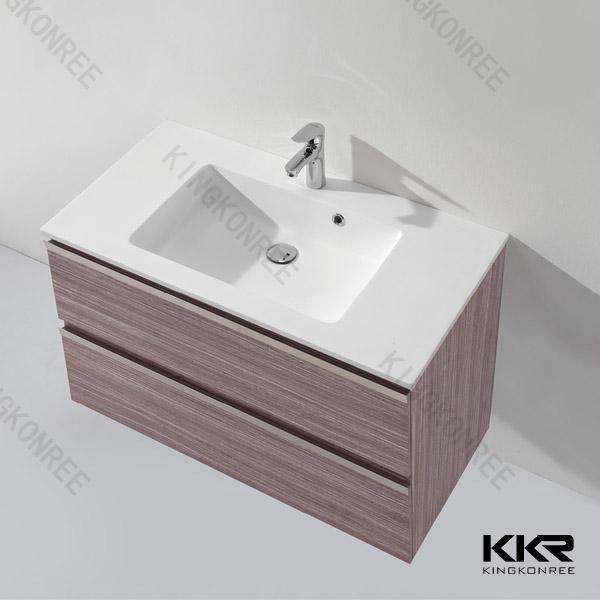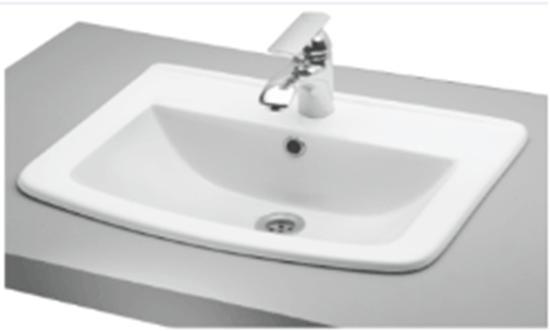The first image is the image on the left, the second image is the image on the right. Assess this claim about the two images: "In both images, a chrome faucet is centered at the back of the bathroom sink unit.". Correct or not? Answer yes or no. Yes. 